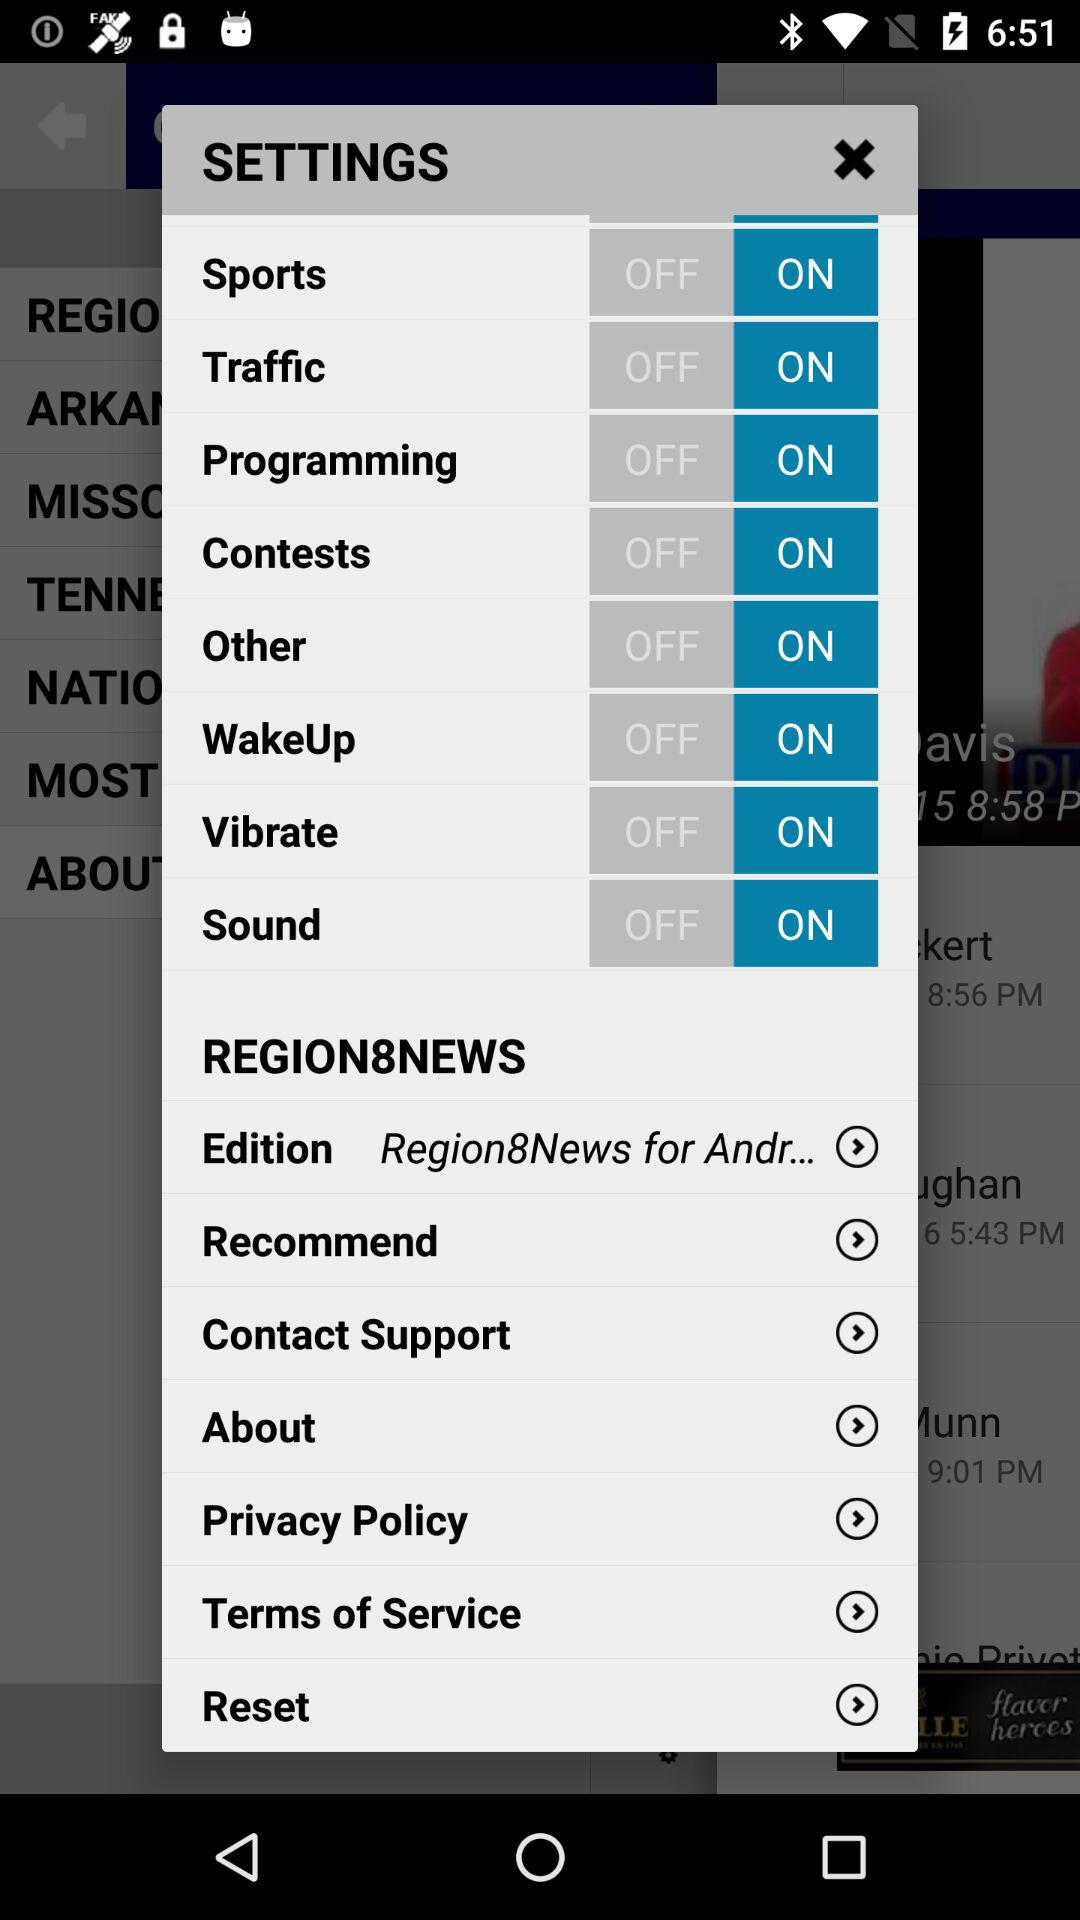What is the status of the "Sports"? The status of the "Sports" is "on". 